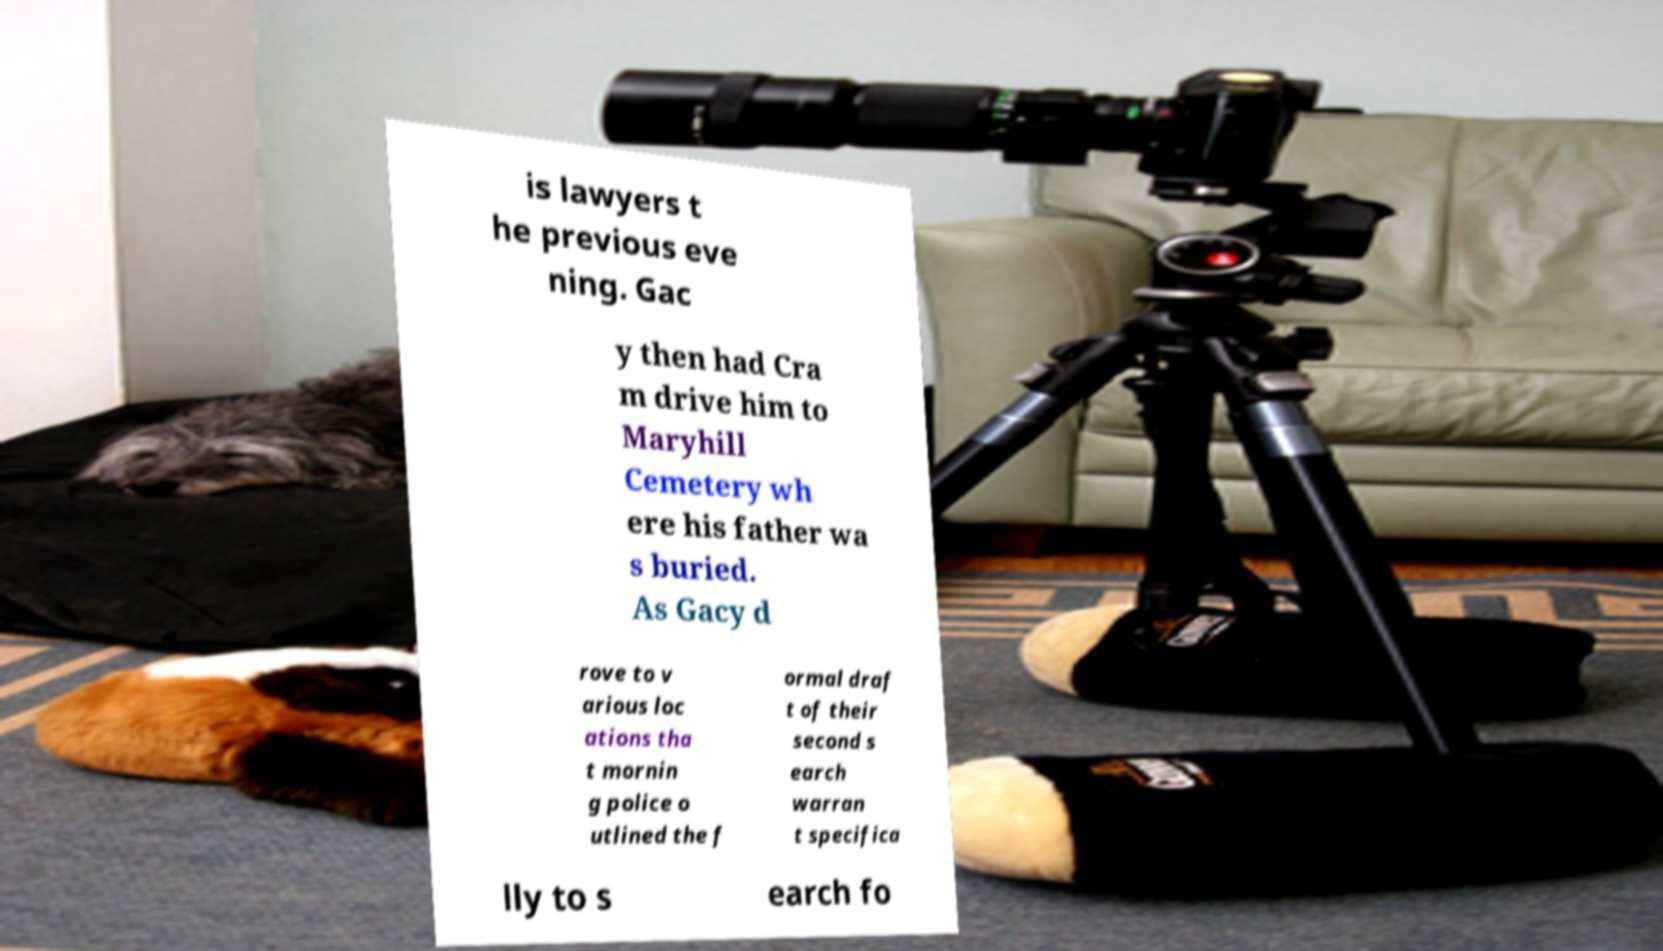Could you extract and type out the text from this image? is lawyers t he previous eve ning. Gac y then had Cra m drive him to Maryhill Cemetery wh ere his father wa s buried. As Gacy d rove to v arious loc ations tha t mornin g police o utlined the f ormal draf t of their second s earch warran t specifica lly to s earch fo 